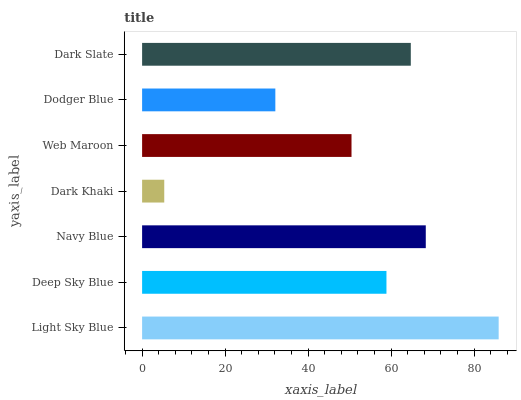Is Dark Khaki the minimum?
Answer yes or no. Yes. Is Light Sky Blue the maximum?
Answer yes or no. Yes. Is Deep Sky Blue the minimum?
Answer yes or no. No. Is Deep Sky Blue the maximum?
Answer yes or no. No. Is Light Sky Blue greater than Deep Sky Blue?
Answer yes or no. Yes. Is Deep Sky Blue less than Light Sky Blue?
Answer yes or no. Yes. Is Deep Sky Blue greater than Light Sky Blue?
Answer yes or no. No. Is Light Sky Blue less than Deep Sky Blue?
Answer yes or no. No. Is Deep Sky Blue the high median?
Answer yes or no. Yes. Is Deep Sky Blue the low median?
Answer yes or no. Yes. Is Light Sky Blue the high median?
Answer yes or no. No. Is Light Sky Blue the low median?
Answer yes or no. No. 